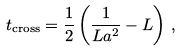Convert formula to latex. <formula><loc_0><loc_0><loc_500><loc_500>t _ { \text {cross} } = \frac { 1 } { 2 } \left ( \frac { 1 } { L a ^ { 2 } } - L \right ) \, ,</formula> 